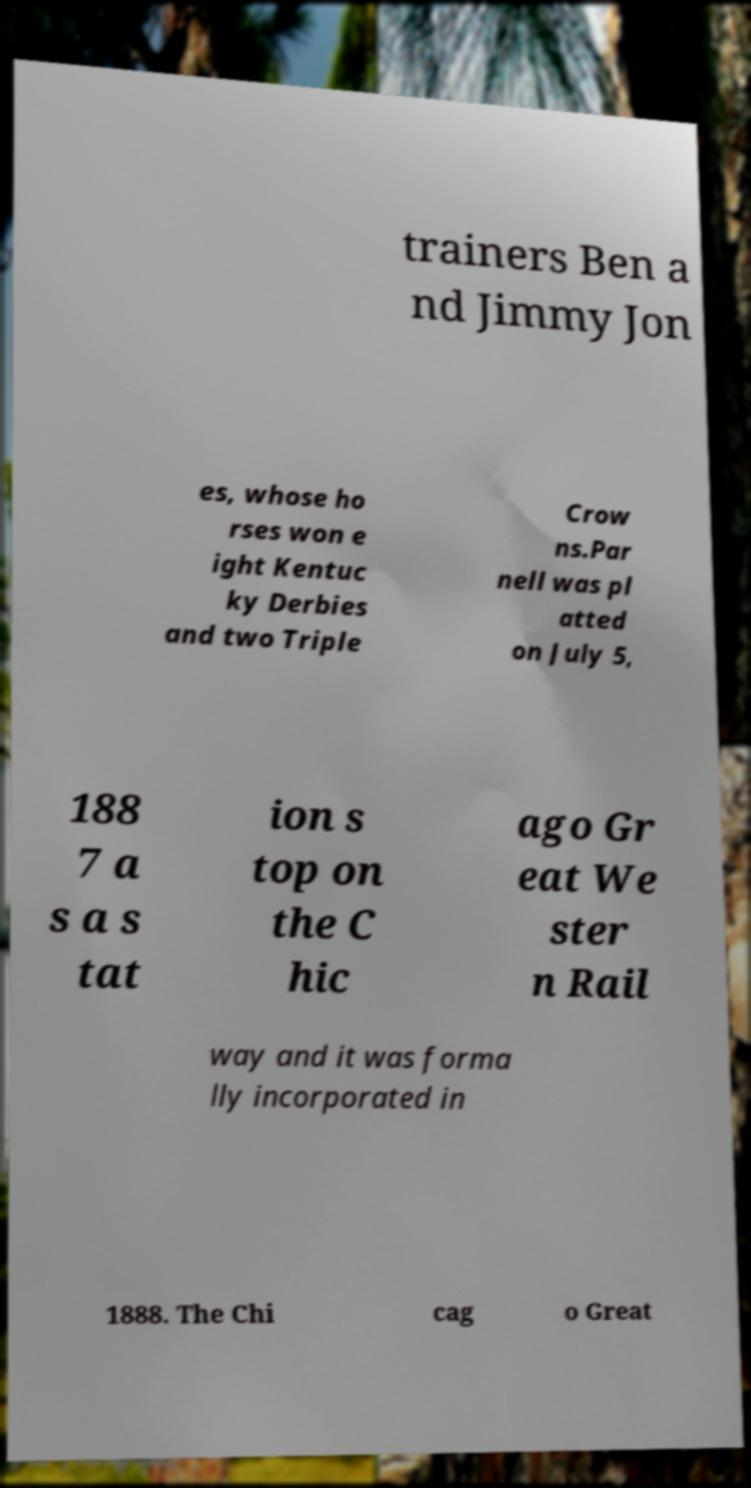There's text embedded in this image that I need extracted. Can you transcribe it verbatim? trainers Ben a nd Jimmy Jon es, whose ho rses won e ight Kentuc ky Derbies and two Triple Crow ns.Par nell was pl atted on July 5, 188 7 a s a s tat ion s top on the C hic ago Gr eat We ster n Rail way and it was forma lly incorporated in 1888. The Chi cag o Great 